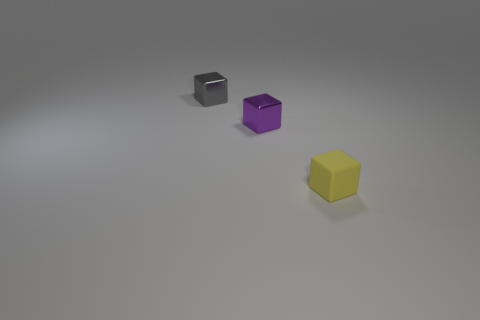Is there anything else that is the same color as the matte block?
Keep it short and to the point. No. Is the size of the gray block the same as the purple metallic thing?
Provide a succinct answer. Yes. Are there any other things that have the same shape as the small purple thing?
Your response must be concise. Yes. There is a tiny purple thing; is it the same shape as the small metallic object to the left of the small purple thing?
Your response must be concise. Yes. How many tiny objects are gray metallic blocks or yellow things?
Keep it short and to the point. 2. Is there a metal thing that has the same size as the purple metallic block?
Make the answer very short. Yes. There is a small thing to the right of the metallic object that is to the right of the tiny block left of the small purple shiny cube; what color is it?
Offer a very short reply. Yellow. Are the gray cube and the tiny object in front of the purple thing made of the same material?
Your answer should be very brief. No. What is the size of the purple shiny object that is the same shape as the yellow matte object?
Your answer should be very brief. Small. Are there an equal number of yellow rubber blocks that are behind the yellow matte block and tiny purple shiny cubes that are right of the small purple thing?
Your answer should be compact. Yes. 